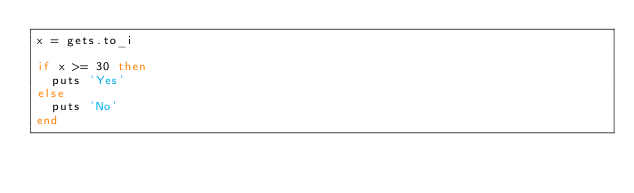<code> <loc_0><loc_0><loc_500><loc_500><_Ruby_>x = gets.to_i

if x >= 30 then
	puts 'Yes'
else
	puts 'No'
end</code> 